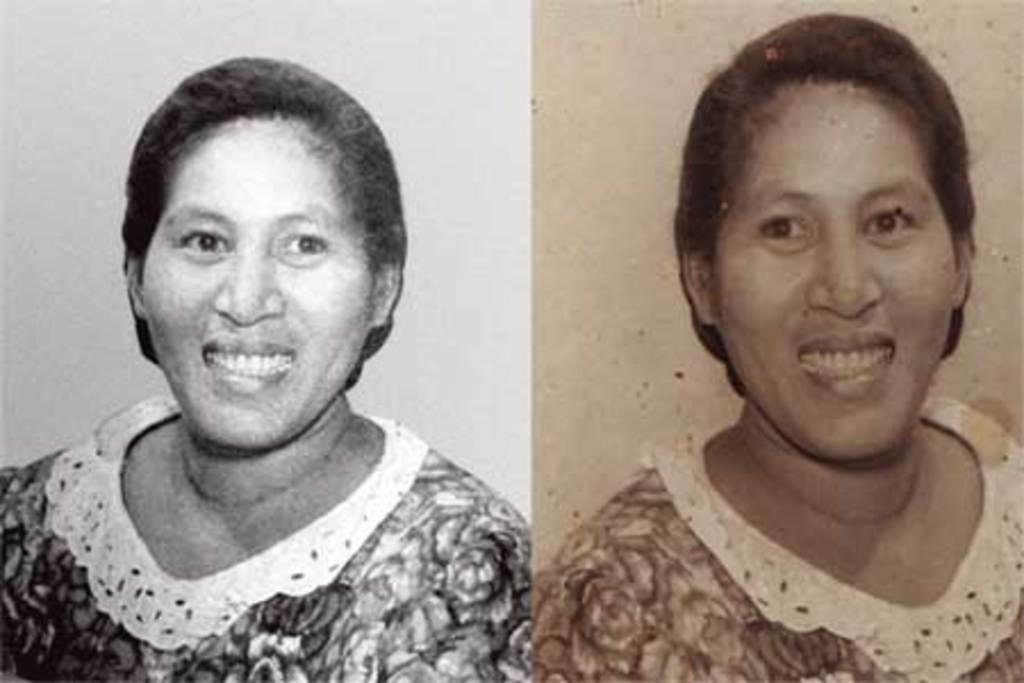Could you give a brief overview of what you see in this image? In the picture I can see collage image of a woman, one is black and white image and another one is shaded image. 